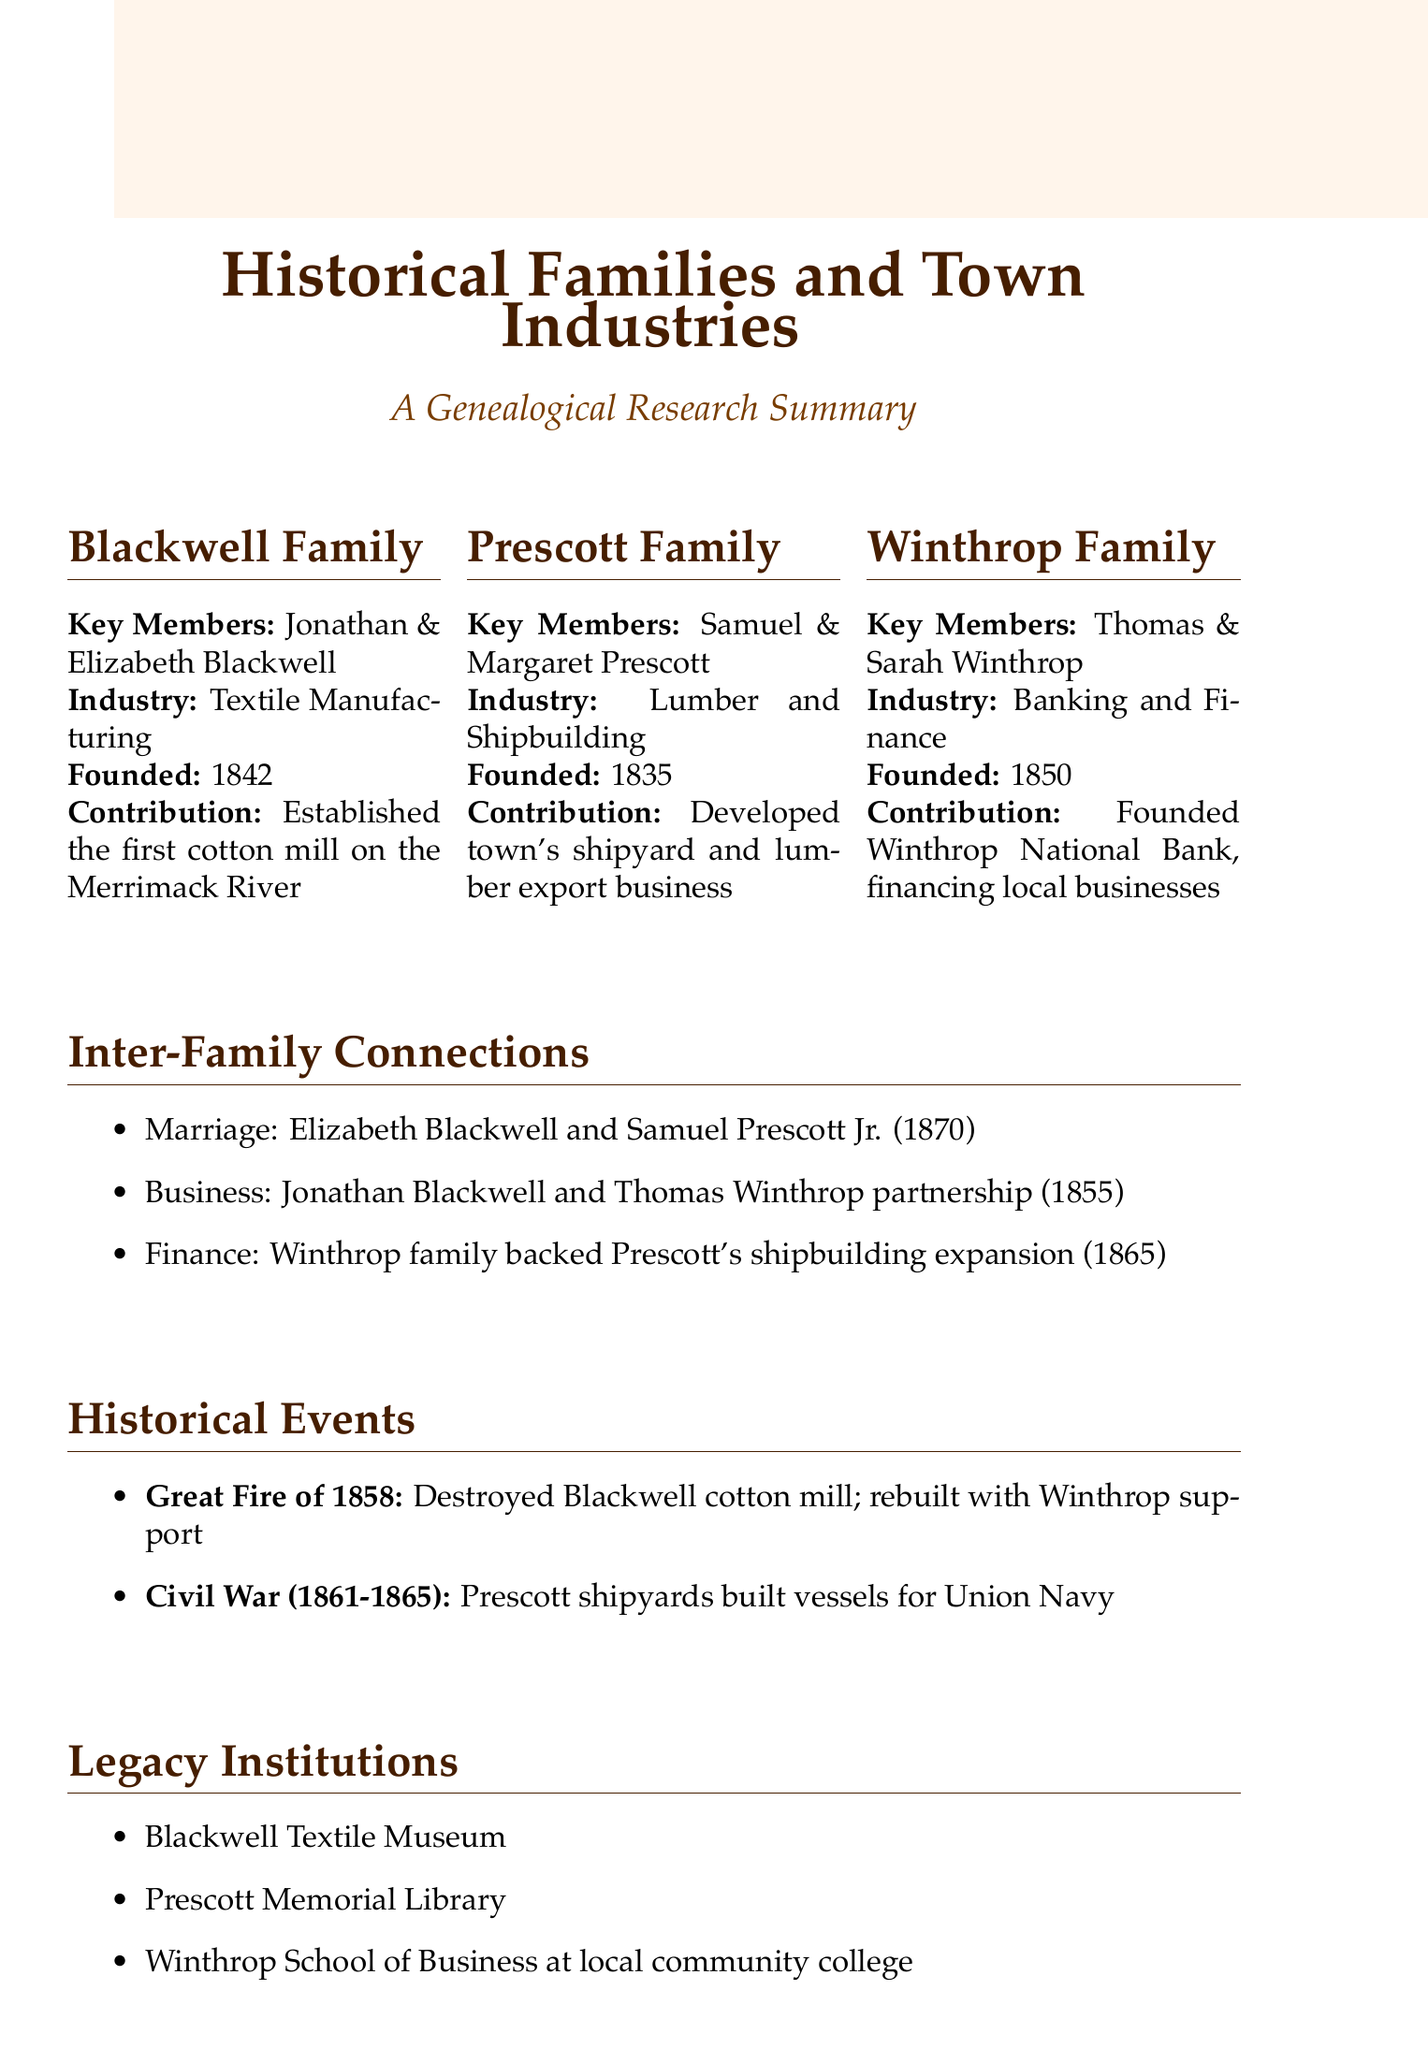What industry did the Blackwell family establish? The Blackwell family is associated with textile manufacturing, as noted in the document.
Answer: Textile Manufacturing What year was the Prescott family industry founded? The founding year of the Prescott family industry, which is lumber and shipbuilding, is provided in the document.
Answer: 1835 Who were the key members of the Winthrop family? The document lists Thomas and Sarah Winthrop as the key members of the Winthrop family.
Answer: Thomas Winthrop, Sarah Winthrop What significant contribution did the Blackwell family make? The document details that the Blackwell family established the first cotton mill on the banks of the Merrimack River.
Answer: Established the first cotton mill on the banks of the Merrimack River What year did the marriage between Elizabeth Blackwell and Samuel Prescott Jr. occur? The document states the year of the marriage between Elizabeth Blackwell and Samuel Prescott Jr. in the inter-family connections section.
Answer: 1870 Which family founded the Winthrop National Bank? The document mentions that the Winthrop family founded the Winthrop National Bank.
Answer: Winthrop family What impact did the Great Fire of 1858 have on the Blackwell cotton mill? The document indicates that the Great Fire of 1858 resulted in the destruction of the Blackwell cotton mill, which was later rebuilt.
Answer: Destruction of Blackwell cotton mill, rebuilt with Winthrop financial support Which legacy institution is named after the Prescott family? The document lists Prescott Memorial Library as a legacy institution associated with the Prescott family.
Answer: Prescott Memorial Library How many families are mentioned in the document? The document describes three prominent families and their contributions, as stated in the summary.
Answer: Three 